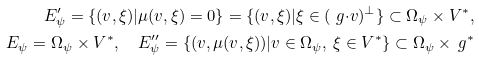Convert formula to latex. <formula><loc_0><loc_0><loc_500><loc_500>E ^ { \prime } _ { \psi } = \{ ( v , \xi ) | \mu ( v , \xi ) = 0 \} = \{ ( v , \xi ) | \xi \in ( \ g { \cdot } v ) ^ { \perp } \} \subset \Omega _ { \psi } \times V ^ { * } , \\ E _ { \psi } = \Omega _ { \psi } \times V ^ { * } , \quad E ^ { \prime \prime } _ { \psi } = \{ ( v , \mu ( v , \xi ) ) | v \in \Omega _ { \psi } , \ \xi \in V ^ { * } \} \subset \Omega _ { \psi } \times \ g ^ { * }</formula> 